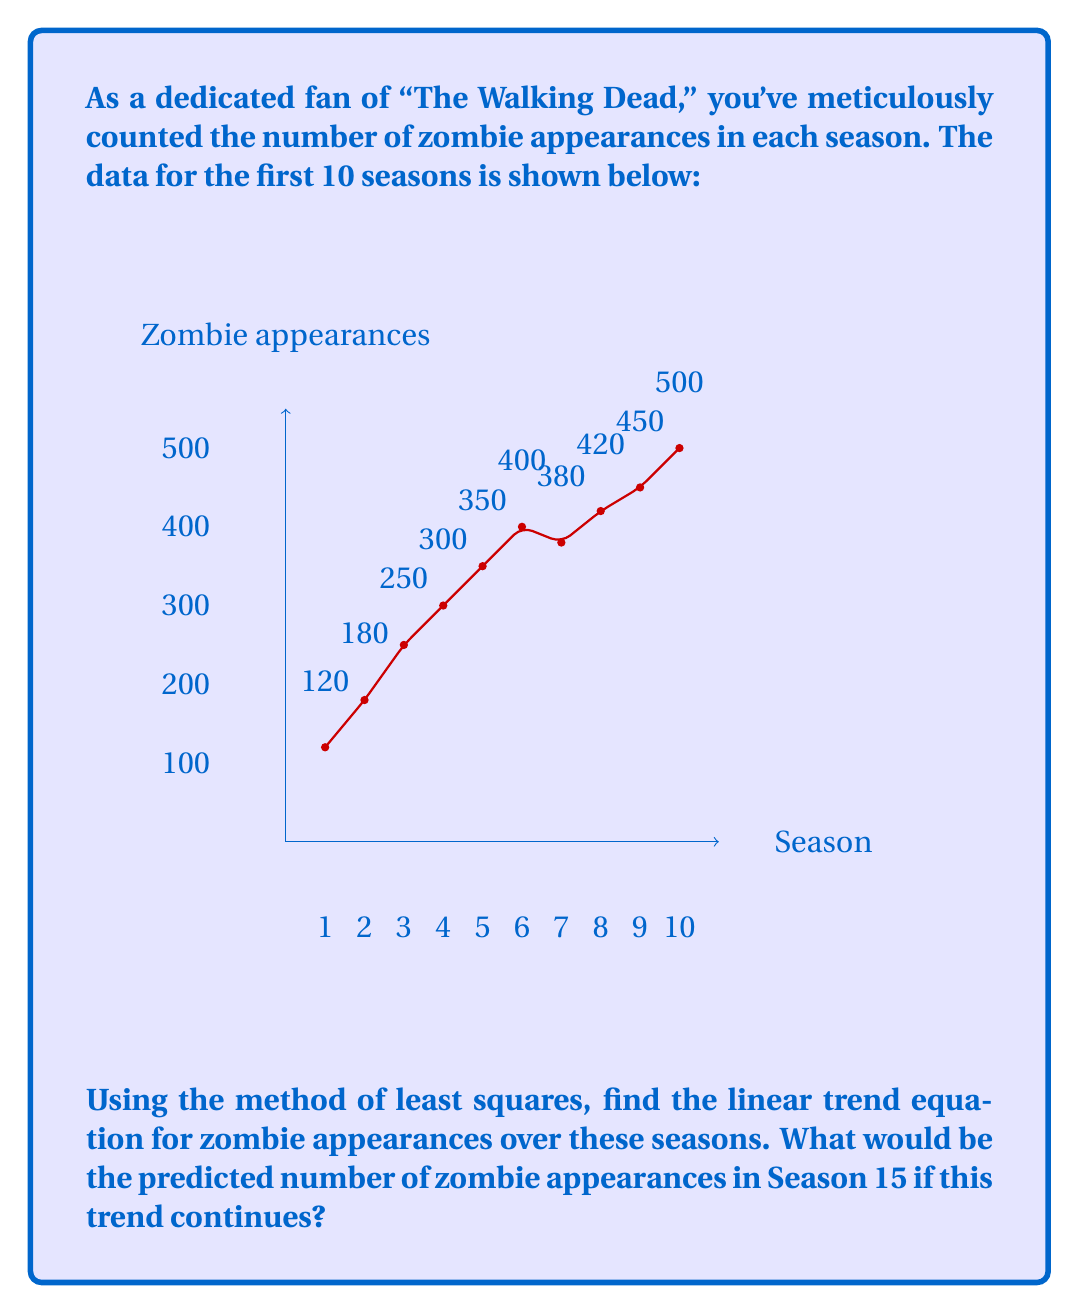Give your solution to this math problem. Let's approach this step-by-step:

1) For a linear trend, we use the equation $y = mx + b$, where $x$ is the season number and $y$ is the number of zombie appearances.

2) To find $m$ and $b$, we use these formulas:
   $m = \frac{n\sum xy - \sum x \sum y}{n\sum x^2 - (\sum x)^2}$
   $b = \frac{\sum y - m\sum x}{n}$

3) First, let's calculate the sums we need:
   $\sum x = 1 + 2 + 3 + ... + 10 = 55$
   $\sum y = 120 + 180 + 250 + ... + 500 = 3350$
   $\sum xy = 1(120) + 2(180) + 3(250) + ... + 10(500) = 22550$
   $\sum x^2 = 1^2 + 2^2 + 3^2 + ... + 10^2 = 385$
   $n = 10$ (number of seasons)

4) Now, let's substitute these into our formulas:
   $m = \frac{10(22550) - 55(3350)}{10(385) - 55^2} = \frac{225500 - 184250}{3850 - 3025} = \frac{41250}{825} = 50$

   $b = \frac{3350 - 50(55)}{10} = \frac{3350 - 2750}{10} = 60$

5) Therefore, our trend line equation is:
   $y = 50x + 60$

6) To predict the number of zombie appearances in Season 15, we substitute $x = 15$:
   $y = 50(15) + 60 = 750 + 60 = 810$
Answer: $y = 50x + 60$; 810 zombie appearances in Season 15 